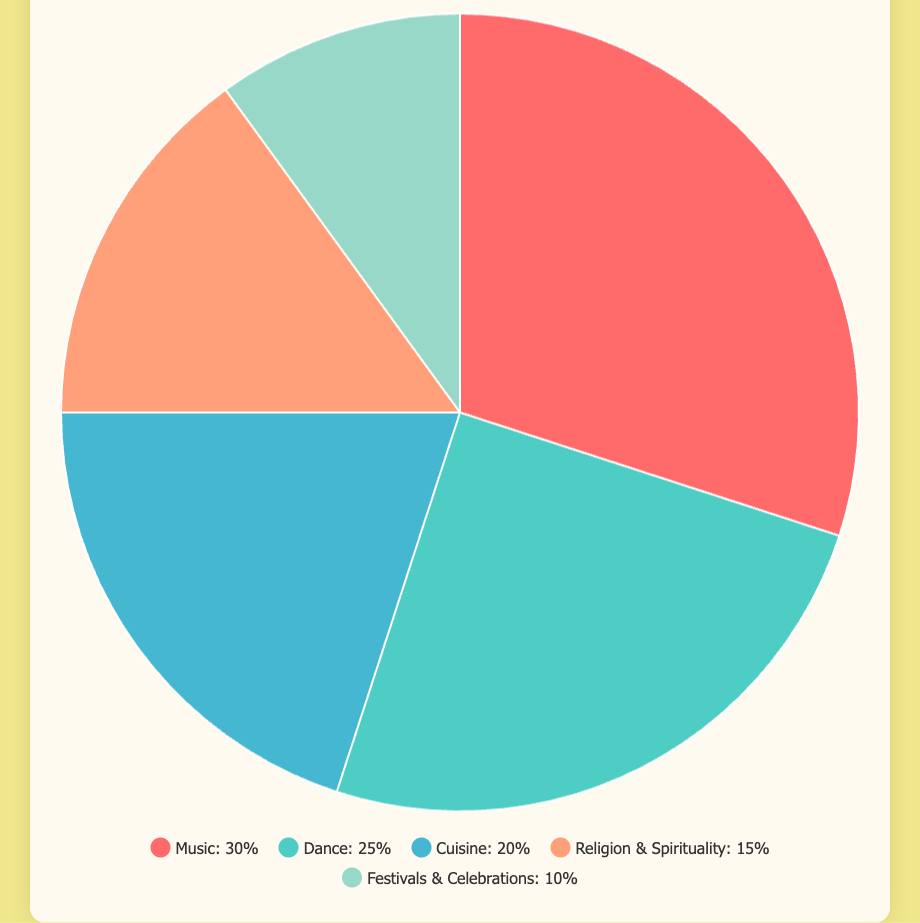What percentage of modern Brazilian culture is contributed by Dance? Dance contributes 25% to modern Brazilian culture, as shown in the pie chart.
Answer: 25% Which category contributes the most to modern Brazilian culture? The category contributing the most is Music, which accounts for 30% of modern Brazilian culture, as indicated by the slice with the largest angle in the pie chart.
Answer: Music What is the difference in contribution between Cuisine and Festivals & Celebrations? The contribution of Cuisine is 20% and Festivals & Celebrations is 10%. The difference is 20% - 10% = 10%.
Answer: 10% What is the combined contribution of Music and Dance to modern Brazilian culture? Music contributes 30% and Dance contributes 25%. The total is 30% + 25% = 55%.
Answer: 55% Which category has the smallest representation in the pie chart? The category with the smallest representation is Festivals & Celebrations, which accounts for 10% of the pie chart.
Answer: Festivals & Celebrations How much greater is the contribution of Music compared to Religion & Spirituality? Music contributes 30%, while Religion & Spirituality contributes 15%. The difference is 30% - 15% = 15%.
Answer: 15% What are the visual attributes of the section representing Cuisine? The section representing Cuisine is colored blue and occupies 20% of the pie chart.
Answer: Blue and 20% Order the categories from the highest to lowest contribution to modern Brazilian culture. The ordered categories are: Music (30%), Dance (25%), Cuisine (20%), Religion & Spirituality (15%), and Festivals & Celebrations (10%).
Answer: Music, Dance, Cuisine, Religion & Spirituality, Festivals & Celebrations If you combined the contributions of Dance, Cuisine, and Religion & Spirituality, what would be the new total? Dance contributes 25%, Cuisine 20%, and Religion & Spirituality 15%. The total is 25% + 20% + 15% = 60%.
Answer: 60% What percentage of the total contribution is made up by non-Music categories? The total contribution is 100%, with Music contributing 30%. The non-Music contributions are 100% - 30% = 70%.
Answer: 70% 